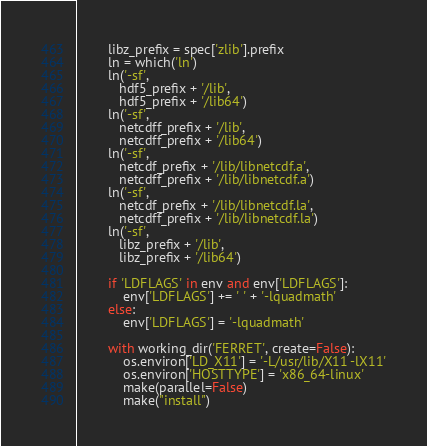Convert code to text. <code><loc_0><loc_0><loc_500><loc_500><_Python_>        libz_prefix = spec['zlib'].prefix
        ln = which('ln')
        ln('-sf',
           hdf5_prefix + '/lib',
           hdf5_prefix + '/lib64')
        ln('-sf',
           netcdff_prefix + '/lib',
           netcdff_prefix + '/lib64')
        ln('-sf',
           netcdf_prefix + '/lib/libnetcdf.a',
           netcdff_prefix + '/lib/libnetcdf.a')
        ln('-sf',
           netcdf_prefix + '/lib/libnetcdf.la',
           netcdff_prefix + '/lib/libnetcdf.la')
        ln('-sf',
           libz_prefix + '/lib',
           libz_prefix + '/lib64')

        if 'LDFLAGS' in env and env['LDFLAGS']:
            env['LDFLAGS'] += ' ' + '-lquadmath'
        else:
            env['LDFLAGS'] = '-lquadmath'

        with working_dir('FERRET', create=False):
            os.environ['LD_X11'] = '-L/usr/lib/X11 -lX11'
            os.environ['HOSTTYPE'] = 'x86_64-linux'
            make(parallel=False)
            make("install")
</code> 